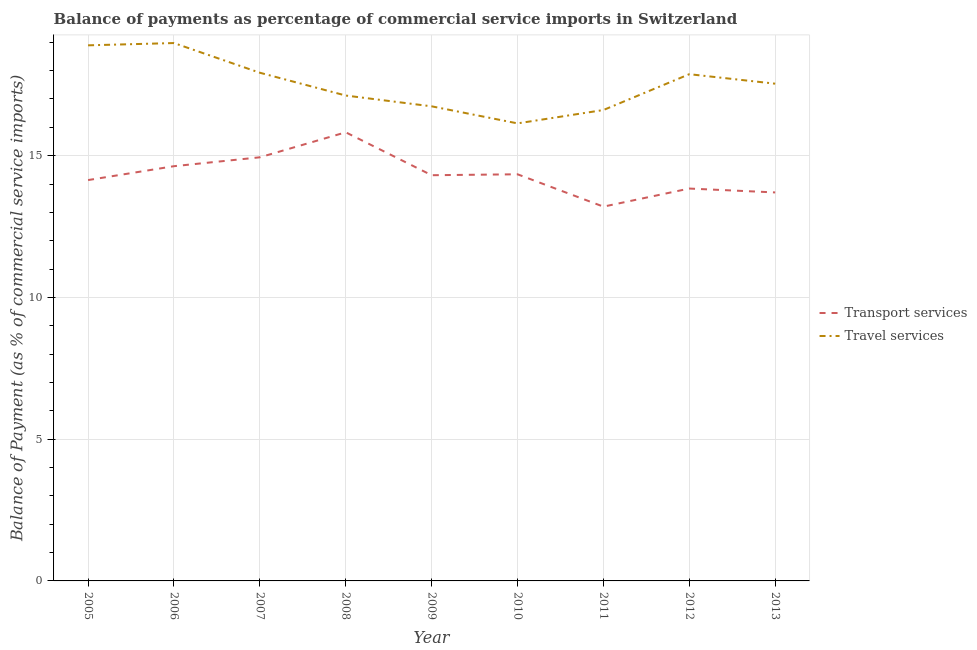Is the number of lines equal to the number of legend labels?
Provide a short and direct response. Yes. What is the balance of payments of travel services in 2012?
Your answer should be very brief. 17.87. Across all years, what is the maximum balance of payments of transport services?
Your answer should be very brief. 15.82. Across all years, what is the minimum balance of payments of travel services?
Ensure brevity in your answer.  16.14. In which year was the balance of payments of transport services maximum?
Ensure brevity in your answer.  2008. In which year was the balance of payments of travel services minimum?
Your answer should be compact. 2010. What is the total balance of payments of transport services in the graph?
Provide a short and direct response. 128.93. What is the difference between the balance of payments of travel services in 2007 and that in 2012?
Offer a very short reply. 0.05. What is the difference between the balance of payments of transport services in 2012 and the balance of payments of travel services in 2010?
Your answer should be compact. -2.3. What is the average balance of payments of transport services per year?
Your answer should be very brief. 14.33. In the year 2007, what is the difference between the balance of payments of travel services and balance of payments of transport services?
Make the answer very short. 2.98. In how many years, is the balance of payments of transport services greater than 11 %?
Offer a very short reply. 9. What is the ratio of the balance of payments of travel services in 2007 to that in 2013?
Provide a short and direct response. 1.02. Is the difference between the balance of payments of travel services in 2005 and 2010 greater than the difference between the balance of payments of transport services in 2005 and 2010?
Provide a short and direct response. Yes. What is the difference between the highest and the second highest balance of payments of travel services?
Provide a succinct answer. 0.08. What is the difference between the highest and the lowest balance of payments of transport services?
Offer a terse response. 2.62. In how many years, is the balance of payments of transport services greater than the average balance of payments of transport services taken over all years?
Provide a succinct answer. 4. Is the balance of payments of travel services strictly greater than the balance of payments of transport services over the years?
Ensure brevity in your answer.  Yes. How many lines are there?
Make the answer very short. 2. How many years are there in the graph?
Your answer should be very brief. 9. What is the difference between two consecutive major ticks on the Y-axis?
Make the answer very short. 5. Are the values on the major ticks of Y-axis written in scientific E-notation?
Provide a short and direct response. No. Does the graph contain grids?
Make the answer very short. Yes. Where does the legend appear in the graph?
Your answer should be very brief. Center right. How many legend labels are there?
Keep it short and to the point. 2. How are the legend labels stacked?
Make the answer very short. Vertical. What is the title of the graph?
Offer a terse response. Balance of payments as percentage of commercial service imports in Switzerland. What is the label or title of the X-axis?
Your answer should be very brief. Year. What is the label or title of the Y-axis?
Ensure brevity in your answer.  Balance of Payment (as % of commercial service imports). What is the Balance of Payment (as % of commercial service imports) in Transport services in 2005?
Make the answer very short. 14.14. What is the Balance of Payment (as % of commercial service imports) of Travel services in 2005?
Offer a terse response. 18.89. What is the Balance of Payment (as % of commercial service imports) in Transport services in 2006?
Give a very brief answer. 14.63. What is the Balance of Payment (as % of commercial service imports) in Travel services in 2006?
Offer a terse response. 18.97. What is the Balance of Payment (as % of commercial service imports) of Transport services in 2007?
Keep it short and to the point. 14.94. What is the Balance of Payment (as % of commercial service imports) in Travel services in 2007?
Ensure brevity in your answer.  17.92. What is the Balance of Payment (as % of commercial service imports) of Transport services in 2008?
Offer a terse response. 15.82. What is the Balance of Payment (as % of commercial service imports) of Travel services in 2008?
Your response must be concise. 17.12. What is the Balance of Payment (as % of commercial service imports) in Transport services in 2009?
Offer a terse response. 14.31. What is the Balance of Payment (as % of commercial service imports) of Travel services in 2009?
Provide a succinct answer. 16.74. What is the Balance of Payment (as % of commercial service imports) in Transport services in 2010?
Offer a very short reply. 14.34. What is the Balance of Payment (as % of commercial service imports) in Travel services in 2010?
Ensure brevity in your answer.  16.14. What is the Balance of Payment (as % of commercial service imports) in Transport services in 2011?
Offer a very short reply. 13.2. What is the Balance of Payment (as % of commercial service imports) of Travel services in 2011?
Your answer should be compact. 16.61. What is the Balance of Payment (as % of commercial service imports) in Transport services in 2012?
Your answer should be very brief. 13.84. What is the Balance of Payment (as % of commercial service imports) in Travel services in 2012?
Your answer should be compact. 17.87. What is the Balance of Payment (as % of commercial service imports) of Transport services in 2013?
Your answer should be very brief. 13.7. What is the Balance of Payment (as % of commercial service imports) of Travel services in 2013?
Offer a very short reply. 17.54. Across all years, what is the maximum Balance of Payment (as % of commercial service imports) in Transport services?
Ensure brevity in your answer.  15.82. Across all years, what is the maximum Balance of Payment (as % of commercial service imports) in Travel services?
Your answer should be compact. 18.97. Across all years, what is the minimum Balance of Payment (as % of commercial service imports) in Transport services?
Give a very brief answer. 13.2. Across all years, what is the minimum Balance of Payment (as % of commercial service imports) of Travel services?
Keep it short and to the point. 16.14. What is the total Balance of Payment (as % of commercial service imports) in Transport services in the graph?
Make the answer very short. 128.93. What is the total Balance of Payment (as % of commercial service imports) in Travel services in the graph?
Your answer should be very brief. 157.81. What is the difference between the Balance of Payment (as % of commercial service imports) in Transport services in 2005 and that in 2006?
Keep it short and to the point. -0.49. What is the difference between the Balance of Payment (as % of commercial service imports) in Travel services in 2005 and that in 2006?
Your answer should be compact. -0.08. What is the difference between the Balance of Payment (as % of commercial service imports) of Transport services in 2005 and that in 2007?
Ensure brevity in your answer.  -0.8. What is the difference between the Balance of Payment (as % of commercial service imports) of Travel services in 2005 and that in 2007?
Your response must be concise. 0.97. What is the difference between the Balance of Payment (as % of commercial service imports) of Transport services in 2005 and that in 2008?
Your answer should be compact. -1.68. What is the difference between the Balance of Payment (as % of commercial service imports) in Travel services in 2005 and that in 2008?
Your answer should be very brief. 1.77. What is the difference between the Balance of Payment (as % of commercial service imports) in Transport services in 2005 and that in 2009?
Ensure brevity in your answer.  -0.17. What is the difference between the Balance of Payment (as % of commercial service imports) in Travel services in 2005 and that in 2009?
Offer a terse response. 2.15. What is the difference between the Balance of Payment (as % of commercial service imports) in Transport services in 2005 and that in 2010?
Make the answer very short. -0.2. What is the difference between the Balance of Payment (as % of commercial service imports) in Travel services in 2005 and that in 2010?
Make the answer very short. 2.75. What is the difference between the Balance of Payment (as % of commercial service imports) of Transport services in 2005 and that in 2011?
Make the answer very short. 0.94. What is the difference between the Balance of Payment (as % of commercial service imports) of Travel services in 2005 and that in 2011?
Offer a terse response. 2.28. What is the difference between the Balance of Payment (as % of commercial service imports) of Transport services in 2005 and that in 2012?
Your answer should be very brief. 0.3. What is the difference between the Balance of Payment (as % of commercial service imports) of Travel services in 2005 and that in 2012?
Offer a terse response. 1.02. What is the difference between the Balance of Payment (as % of commercial service imports) in Transport services in 2005 and that in 2013?
Offer a very short reply. 0.44. What is the difference between the Balance of Payment (as % of commercial service imports) in Travel services in 2005 and that in 2013?
Keep it short and to the point. 1.35. What is the difference between the Balance of Payment (as % of commercial service imports) in Transport services in 2006 and that in 2007?
Provide a short and direct response. -0.31. What is the difference between the Balance of Payment (as % of commercial service imports) in Travel services in 2006 and that in 2007?
Provide a succinct answer. 1.05. What is the difference between the Balance of Payment (as % of commercial service imports) of Transport services in 2006 and that in 2008?
Offer a terse response. -1.2. What is the difference between the Balance of Payment (as % of commercial service imports) of Travel services in 2006 and that in 2008?
Provide a short and direct response. 1.85. What is the difference between the Balance of Payment (as % of commercial service imports) in Transport services in 2006 and that in 2009?
Give a very brief answer. 0.32. What is the difference between the Balance of Payment (as % of commercial service imports) of Travel services in 2006 and that in 2009?
Offer a very short reply. 2.23. What is the difference between the Balance of Payment (as % of commercial service imports) in Transport services in 2006 and that in 2010?
Keep it short and to the point. 0.29. What is the difference between the Balance of Payment (as % of commercial service imports) of Travel services in 2006 and that in 2010?
Your response must be concise. 2.83. What is the difference between the Balance of Payment (as % of commercial service imports) in Transport services in 2006 and that in 2011?
Make the answer very short. 1.43. What is the difference between the Balance of Payment (as % of commercial service imports) in Travel services in 2006 and that in 2011?
Make the answer very short. 2.36. What is the difference between the Balance of Payment (as % of commercial service imports) of Transport services in 2006 and that in 2012?
Your answer should be very brief. 0.79. What is the difference between the Balance of Payment (as % of commercial service imports) in Travel services in 2006 and that in 2012?
Provide a short and direct response. 1.1. What is the difference between the Balance of Payment (as % of commercial service imports) of Transport services in 2006 and that in 2013?
Provide a succinct answer. 0.93. What is the difference between the Balance of Payment (as % of commercial service imports) of Travel services in 2006 and that in 2013?
Offer a very short reply. 1.43. What is the difference between the Balance of Payment (as % of commercial service imports) in Transport services in 2007 and that in 2008?
Ensure brevity in your answer.  -0.88. What is the difference between the Balance of Payment (as % of commercial service imports) in Travel services in 2007 and that in 2008?
Make the answer very short. 0.8. What is the difference between the Balance of Payment (as % of commercial service imports) in Transport services in 2007 and that in 2009?
Provide a short and direct response. 0.63. What is the difference between the Balance of Payment (as % of commercial service imports) in Travel services in 2007 and that in 2009?
Provide a short and direct response. 1.18. What is the difference between the Balance of Payment (as % of commercial service imports) of Transport services in 2007 and that in 2010?
Give a very brief answer. 0.6. What is the difference between the Balance of Payment (as % of commercial service imports) of Travel services in 2007 and that in 2010?
Provide a short and direct response. 1.79. What is the difference between the Balance of Payment (as % of commercial service imports) in Transport services in 2007 and that in 2011?
Your answer should be very brief. 1.74. What is the difference between the Balance of Payment (as % of commercial service imports) in Travel services in 2007 and that in 2011?
Provide a succinct answer. 1.32. What is the difference between the Balance of Payment (as % of commercial service imports) in Transport services in 2007 and that in 2012?
Make the answer very short. 1.1. What is the difference between the Balance of Payment (as % of commercial service imports) of Travel services in 2007 and that in 2012?
Keep it short and to the point. 0.05. What is the difference between the Balance of Payment (as % of commercial service imports) in Transport services in 2007 and that in 2013?
Provide a short and direct response. 1.24. What is the difference between the Balance of Payment (as % of commercial service imports) of Travel services in 2007 and that in 2013?
Make the answer very short. 0.39. What is the difference between the Balance of Payment (as % of commercial service imports) in Transport services in 2008 and that in 2009?
Keep it short and to the point. 1.51. What is the difference between the Balance of Payment (as % of commercial service imports) of Travel services in 2008 and that in 2009?
Provide a succinct answer. 0.38. What is the difference between the Balance of Payment (as % of commercial service imports) of Transport services in 2008 and that in 2010?
Ensure brevity in your answer.  1.48. What is the difference between the Balance of Payment (as % of commercial service imports) of Travel services in 2008 and that in 2010?
Offer a terse response. 0.98. What is the difference between the Balance of Payment (as % of commercial service imports) in Transport services in 2008 and that in 2011?
Make the answer very short. 2.62. What is the difference between the Balance of Payment (as % of commercial service imports) of Travel services in 2008 and that in 2011?
Give a very brief answer. 0.51. What is the difference between the Balance of Payment (as % of commercial service imports) in Transport services in 2008 and that in 2012?
Provide a succinct answer. 1.98. What is the difference between the Balance of Payment (as % of commercial service imports) of Travel services in 2008 and that in 2012?
Your answer should be very brief. -0.75. What is the difference between the Balance of Payment (as % of commercial service imports) of Transport services in 2008 and that in 2013?
Your response must be concise. 2.12. What is the difference between the Balance of Payment (as % of commercial service imports) in Travel services in 2008 and that in 2013?
Ensure brevity in your answer.  -0.42. What is the difference between the Balance of Payment (as % of commercial service imports) in Transport services in 2009 and that in 2010?
Your answer should be compact. -0.03. What is the difference between the Balance of Payment (as % of commercial service imports) in Travel services in 2009 and that in 2010?
Offer a very short reply. 0.6. What is the difference between the Balance of Payment (as % of commercial service imports) of Transport services in 2009 and that in 2011?
Offer a terse response. 1.11. What is the difference between the Balance of Payment (as % of commercial service imports) of Travel services in 2009 and that in 2011?
Give a very brief answer. 0.13. What is the difference between the Balance of Payment (as % of commercial service imports) of Transport services in 2009 and that in 2012?
Your response must be concise. 0.47. What is the difference between the Balance of Payment (as % of commercial service imports) in Travel services in 2009 and that in 2012?
Make the answer very short. -1.13. What is the difference between the Balance of Payment (as % of commercial service imports) of Transport services in 2009 and that in 2013?
Ensure brevity in your answer.  0.61. What is the difference between the Balance of Payment (as % of commercial service imports) in Travel services in 2009 and that in 2013?
Make the answer very short. -0.8. What is the difference between the Balance of Payment (as % of commercial service imports) of Transport services in 2010 and that in 2011?
Ensure brevity in your answer.  1.14. What is the difference between the Balance of Payment (as % of commercial service imports) of Travel services in 2010 and that in 2011?
Offer a very short reply. -0.47. What is the difference between the Balance of Payment (as % of commercial service imports) of Transport services in 2010 and that in 2012?
Provide a succinct answer. 0.5. What is the difference between the Balance of Payment (as % of commercial service imports) of Travel services in 2010 and that in 2012?
Give a very brief answer. -1.74. What is the difference between the Balance of Payment (as % of commercial service imports) in Transport services in 2010 and that in 2013?
Your answer should be compact. 0.64. What is the difference between the Balance of Payment (as % of commercial service imports) of Travel services in 2010 and that in 2013?
Offer a very short reply. -1.4. What is the difference between the Balance of Payment (as % of commercial service imports) of Transport services in 2011 and that in 2012?
Your answer should be compact. -0.64. What is the difference between the Balance of Payment (as % of commercial service imports) in Travel services in 2011 and that in 2012?
Your answer should be compact. -1.26. What is the difference between the Balance of Payment (as % of commercial service imports) in Transport services in 2011 and that in 2013?
Offer a very short reply. -0.5. What is the difference between the Balance of Payment (as % of commercial service imports) in Travel services in 2011 and that in 2013?
Offer a terse response. -0.93. What is the difference between the Balance of Payment (as % of commercial service imports) in Transport services in 2012 and that in 2013?
Your response must be concise. 0.14. What is the difference between the Balance of Payment (as % of commercial service imports) in Travel services in 2012 and that in 2013?
Your answer should be compact. 0.33. What is the difference between the Balance of Payment (as % of commercial service imports) of Transport services in 2005 and the Balance of Payment (as % of commercial service imports) of Travel services in 2006?
Provide a succinct answer. -4.83. What is the difference between the Balance of Payment (as % of commercial service imports) in Transport services in 2005 and the Balance of Payment (as % of commercial service imports) in Travel services in 2007?
Your answer should be compact. -3.79. What is the difference between the Balance of Payment (as % of commercial service imports) of Transport services in 2005 and the Balance of Payment (as % of commercial service imports) of Travel services in 2008?
Give a very brief answer. -2.98. What is the difference between the Balance of Payment (as % of commercial service imports) in Transport services in 2005 and the Balance of Payment (as % of commercial service imports) in Travel services in 2009?
Offer a terse response. -2.6. What is the difference between the Balance of Payment (as % of commercial service imports) of Transport services in 2005 and the Balance of Payment (as % of commercial service imports) of Travel services in 2010?
Your response must be concise. -2. What is the difference between the Balance of Payment (as % of commercial service imports) in Transport services in 2005 and the Balance of Payment (as % of commercial service imports) in Travel services in 2011?
Your answer should be very brief. -2.47. What is the difference between the Balance of Payment (as % of commercial service imports) of Transport services in 2005 and the Balance of Payment (as % of commercial service imports) of Travel services in 2012?
Your answer should be very brief. -3.73. What is the difference between the Balance of Payment (as % of commercial service imports) in Transport services in 2005 and the Balance of Payment (as % of commercial service imports) in Travel services in 2013?
Make the answer very short. -3.4. What is the difference between the Balance of Payment (as % of commercial service imports) in Transport services in 2006 and the Balance of Payment (as % of commercial service imports) in Travel services in 2007?
Offer a terse response. -3.3. What is the difference between the Balance of Payment (as % of commercial service imports) in Transport services in 2006 and the Balance of Payment (as % of commercial service imports) in Travel services in 2008?
Your answer should be very brief. -2.49. What is the difference between the Balance of Payment (as % of commercial service imports) in Transport services in 2006 and the Balance of Payment (as % of commercial service imports) in Travel services in 2009?
Your answer should be compact. -2.11. What is the difference between the Balance of Payment (as % of commercial service imports) in Transport services in 2006 and the Balance of Payment (as % of commercial service imports) in Travel services in 2010?
Your answer should be compact. -1.51. What is the difference between the Balance of Payment (as % of commercial service imports) in Transport services in 2006 and the Balance of Payment (as % of commercial service imports) in Travel services in 2011?
Ensure brevity in your answer.  -1.98. What is the difference between the Balance of Payment (as % of commercial service imports) of Transport services in 2006 and the Balance of Payment (as % of commercial service imports) of Travel services in 2012?
Your response must be concise. -3.25. What is the difference between the Balance of Payment (as % of commercial service imports) in Transport services in 2006 and the Balance of Payment (as % of commercial service imports) in Travel services in 2013?
Offer a very short reply. -2.91. What is the difference between the Balance of Payment (as % of commercial service imports) of Transport services in 2007 and the Balance of Payment (as % of commercial service imports) of Travel services in 2008?
Provide a succinct answer. -2.18. What is the difference between the Balance of Payment (as % of commercial service imports) in Transport services in 2007 and the Balance of Payment (as % of commercial service imports) in Travel services in 2009?
Make the answer very short. -1.8. What is the difference between the Balance of Payment (as % of commercial service imports) in Transport services in 2007 and the Balance of Payment (as % of commercial service imports) in Travel services in 2010?
Your answer should be compact. -1.2. What is the difference between the Balance of Payment (as % of commercial service imports) of Transport services in 2007 and the Balance of Payment (as % of commercial service imports) of Travel services in 2011?
Make the answer very short. -1.67. What is the difference between the Balance of Payment (as % of commercial service imports) in Transport services in 2007 and the Balance of Payment (as % of commercial service imports) in Travel services in 2012?
Provide a short and direct response. -2.93. What is the difference between the Balance of Payment (as % of commercial service imports) of Transport services in 2007 and the Balance of Payment (as % of commercial service imports) of Travel services in 2013?
Make the answer very short. -2.6. What is the difference between the Balance of Payment (as % of commercial service imports) in Transport services in 2008 and the Balance of Payment (as % of commercial service imports) in Travel services in 2009?
Provide a short and direct response. -0.92. What is the difference between the Balance of Payment (as % of commercial service imports) in Transport services in 2008 and the Balance of Payment (as % of commercial service imports) in Travel services in 2010?
Ensure brevity in your answer.  -0.31. What is the difference between the Balance of Payment (as % of commercial service imports) in Transport services in 2008 and the Balance of Payment (as % of commercial service imports) in Travel services in 2011?
Ensure brevity in your answer.  -0.79. What is the difference between the Balance of Payment (as % of commercial service imports) in Transport services in 2008 and the Balance of Payment (as % of commercial service imports) in Travel services in 2012?
Provide a short and direct response. -2.05. What is the difference between the Balance of Payment (as % of commercial service imports) in Transport services in 2008 and the Balance of Payment (as % of commercial service imports) in Travel services in 2013?
Ensure brevity in your answer.  -1.72. What is the difference between the Balance of Payment (as % of commercial service imports) of Transport services in 2009 and the Balance of Payment (as % of commercial service imports) of Travel services in 2010?
Keep it short and to the point. -1.83. What is the difference between the Balance of Payment (as % of commercial service imports) of Transport services in 2009 and the Balance of Payment (as % of commercial service imports) of Travel services in 2011?
Provide a succinct answer. -2.3. What is the difference between the Balance of Payment (as % of commercial service imports) in Transport services in 2009 and the Balance of Payment (as % of commercial service imports) in Travel services in 2012?
Ensure brevity in your answer.  -3.56. What is the difference between the Balance of Payment (as % of commercial service imports) of Transport services in 2009 and the Balance of Payment (as % of commercial service imports) of Travel services in 2013?
Give a very brief answer. -3.23. What is the difference between the Balance of Payment (as % of commercial service imports) of Transport services in 2010 and the Balance of Payment (as % of commercial service imports) of Travel services in 2011?
Ensure brevity in your answer.  -2.27. What is the difference between the Balance of Payment (as % of commercial service imports) of Transport services in 2010 and the Balance of Payment (as % of commercial service imports) of Travel services in 2012?
Make the answer very short. -3.53. What is the difference between the Balance of Payment (as % of commercial service imports) in Transport services in 2010 and the Balance of Payment (as % of commercial service imports) in Travel services in 2013?
Your answer should be very brief. -3.2. What is the difference between the Balance of Payment (as % of commercial service imports) of Transport services in 2011 and the Balance of Payment (as % of commercial service imports) of Travel services in 2012?
Your answer should be compact. -4.67. What is the difference between the Balance of Payment (as % of commercial service imports) of Transport services in 2011 and the Balance of Payment (as % of commercial service imports) of Travel services in 2013?
Your response must be concise. -4.34. What is the difference between the Balance of Payment (as % of commercial service imports) of Transport services in 2012 and the Balance of Payment (as % of commercial service imports) of Travel services in 2013?
Provide a short and direct response. -3.7. What is the average Balance of Payment (as % of commercial service imports) of Transport services per year?
Give a very brief answer. 14.33. What is the average Balance of Payment (as % of commercial service imports) of Travel services per year?
Keep it short and to the point. 17.53. In the year 2005, what is the difference between the Balance of Payment (as % of commercial service imports) of Transport services and Balance of Payment (as % of commercial service imports) of Travel services?
Ensure brevity in your answer.  -4.75. In the year 2006, what is the difference between the Balance of Payment (as % of commercial service imports) of Transport services and Balance of Payment (as % of commercial service imports) of Travel services?
Give a very brief answer. -4.34. In the year 2007, what is the difference between the Balance of Payment (as % of commercial service imports) in Transport services and Balance of Payment (as % of commercial service imports) in Travel services?
Ensure brevity in your answer.  -2.98. In the year 2008, what is the difference between the Balance of Payment (as % of commercial service imports) of Transport services and Balance of Payment (as % of commercial service imports) of Travel services?
Make the answer very short. -1.3. In the year 2009, what is the difference between the Balance of Payment (as % of commercial service imports) in Transport services and Balance of Payment (as % of commercial service imports) in Travel services?
Offer a very short reply. -2.43. In the year 2010, what is the difference between the Balance of Payment (as % of commercial service imports) in Transport services and Balance of Payment (as % of commercial service imports) in Travel services?
Your answer should be very brief. -1.8. In the year 2011, what is the difference between the Balance of Payment (as % of commercial service imports) of Transport services and Balance of Payment (as % of commercial service imports) of Travel services?
Provide a succinct answer. -3.41. In the year 2012, what is the difference between the Balance of Payment (as % of commercial service imports) of Transport services and Balance of Payment (as % of commercial service imports) of Travel services?
Make the answer very short. -4.03. In the year 2013, what is the difference between the Balance of Payment (as % of commercial service imports) in Transport services and Balance of Payment (as % of commercial service imports) in Travel services?
Your answer should be compact. -3.84. What is the ratio of the Balance of Payment (as % of commercial service imports) in Transport services in 2005 to that in 2006?
Offer a very short reply. 0.97. What is the ratio of the Balance of Payment (as % of commercial service imports) in Transport services in 2005 to that in 2007?
Your response must be concise. 0.95. What is the ratio of the Balance of Payment (as % of commercial service imports) in Travel services in 2005 to that in 2007?
Keep it short and to the point. 1.05. What is the ratio of the Balance of Payment (as % of commercial service imports) in Transport services in 2005 to that in 2008?
Your answer should be compact. 0.89. What is the ratio of the Balance of Payment (as % of commercial service imports) in Travel services in 2005 to that in 2008?
Give a very brief answer. 1.1. What is the ratio of the Balance of Payment (as % of commercial service imports) in Travel services in 2005 to that in 2009?
Provide a succinct answer. 1.13. What is the ratio of the Balance of Payment (as % of commercial service imports) in Transport services in 2005 to that in 2010?
Offer a terse response. 0.99. What is the ratio of the Balance of Payment (as % of commercial service imports) in Travel services in 2005 to that in 2010?
Provide a succinct answer. 1.17. What is the ratio of the Balance of Payment (as % of commercial service imports) in Transport services in 2005 to that in 2011?
Keep it short and to the point. 1.07. What is the ratio of the Balance of Payment (as % of commercial service imports) of Travel services in 2005 to that in 2011?
Offer a very short reply. 1.14. What is the ratio of the Balance of Payment (as % of commercial service imports) in Transport services in 2005 to that in 2012?
Provide a short and direct response. 1.02. What is the ratio of the Balance of Payment (as % of commercial service imports) in Travel services in 2005 to that in 2012?
Offer a terse response. 1.06. What is the ratio of the Balance of Payment (as % of commercial service imports) of Transport services in 2005 to that in 2013?
Make the answer very short. 1.03. What is the ratio of the Balance of Payment (as % of commercial service imports) in Travel services in 2005 to that in 2013?
Ensure brevity in your answer.  1.08. What is the ratio of the Balance of Payment (as % of commercial service imports) of Travel services in 2006 to that in 2007?
Provide a succinct answer. 1.06. What is the ratio of the Balance of Payment (as % of commercial service imports) in Transport services in 2006 to that in 2008?
Your answer should be very brief. 0.92. What is the ratio of the Balance of Payment (as % of commercial service imports) of Travel services in 2006 to that in 2008?
Offer a very short reply. 1.11. What is the ratio of the Balance of Payment (as % of commercial service imports) of Transport services in 2006 to that in 2009?
Keep it short and to the point. 1.02. What is the ratio of the Balance of Payment (as % of commercial service imports) of Travel services in 2006 to that in 2009?
Make the answer very short. 1.13. What is the ratio of the Balance of Payment (as % of commercial service imports) in Transport services in 2006 to that in 2010?
Make the answer very short. 1.02. What is the ratio of the Balance of Payment (as % of commercial service imports) of Travel services in 2006 to that in 2010?
Provide a short and direct response. 1.18. What is the ratio of the Balance of Payment (as % of commercial service imports) of Transport services in 2006 to that in 2011?
Provide a short and direct response. 1.11. What is the ratio of the Balance of Payment (as % of commercial service imports) in Travel services in 2006 to that in 2011?
Make the answer very short. 1.14. What is the ratio of the Balance of Payment (as % of commercial service imports) of Transport services in 2006 to that in 2012?
Give a very brief answer. 1.06. What is the ratio of the Balance of Payment (as % of commercial service imports) in Travel services in 2006 to that in 2012?
Your answer should be compact. 1.06. What is the ratio of the Balance of Payment (as % of commercial service imports) of Transport services in 2006 to that in 2013?
Offer a terse response. 1.07. What is the ratio of the Balance of Payment (as % of commercial service imports) of Travel services in 2006 to that in 2013?
Provide a short and direct response. 1.08. What is the ratio of the Balance of Payment (as % of commercial service imports) of Transport services in 2007 to that in 2008?
Ensure brevity in your answer.  0.94. What is the ratio of the Balance of Payment (as % of commercial service imports) of Travel services in 2007 to that in 2008?
Ensure brevity in your answer.  1.05. What is the ratio of the Balance of Payment (as % of commercial service imports) of Transport services in 2007 to that in 2009?
Keep it short and to the point. 1.04. What is the ratio of the Balance of Payment (as % of commercial service imports) of Travel services in 2007 to that in 2009?
Your response must be concise. 1.07. What is the ratio of the Balance of Payment (as % of commercial service imports) in Transport services in 2007 to that in 2010?
Your answer should be compact. 1.04. What is the ratio of the Balance of Payment (as % of commercial service imports) of Travel services in 2007 to that in 2010?
Make the answer very short. 1.11. What is the ratio of the Balance of Payment (as % of commercial service imports) in Transport services in 2007 to that in 2011?
Offer a very short reply. 1.13. What is the ratio of the Balance of Payment (as % of commercial service imports) in Travel services in 2007 to that in 2011?
Your response must be concise. 1.08. What is the ratio of the Balance of Payment (as % of commercial service imports) in Transport services in 2007 to that in 2012?
Offer a very short reply. 1.08. What is the ratio of the Balance of Payment (as % of commercial service imports) of Transport services in 2007 to that in 2013?
Make the answer very short. 1.09. What is the ratio of the Balance of Payment (as % of commercial service imports) of Transport services in 2008 to that in 2009?
Your response must be concise. 1.11. What is the ratio of the Balance of Payment (as % of commercial service imports) of Travel services in 2008 to that in 2009?
Your answer should be compact. 1.02. What is the ratio of the Balance of Payment (as % of commercial service imports) of Transport services in 2008 to that in 2010?
Make the answer very short. 1.1. What is the ratio of the Balance of Payment (as % of commercial service imports) of Travel services in 2008 to that in 2010?
Ensure brevity in your answer.  1.06. What is the ratio of the Balance of Payment (as % of commercial service imports) in Transport services in 2008 to that in 2011?
Offer a very short reply. 1.2. What is the ratio of the Balance of Payment (as % of commercial service imports) of Travel services in 2008 to that in 2011?
Make the answer very short. 1.03. What is the ratio of the Balance of Payment (as % of commercial service imports) of Transport services in 2008 to that in 2012?
Ensure brevity in your answer.  1.14. What is the ratio of the Balance of Payment (as % of commercial service imports) in Travel services in 2008 to that in 2012?
Offer a terse response. 0.96. What is the ratio of the Balance of Payment (as % of commercial service imports) of Transport services in 2008 to that in 2013?
Make the answer very short. 1.15. What is the ratio of the Balance of Payment (as % of commercial service imports) of Travel services in 2008 to that in 2013?
Your response must be concise. 0.98. What is the ratio of the Balance of Payment (as % of commercial service imports) in Travel services in 2009 to that in 2010?
Your answer should be compact. 1.04. What is the ratio of the Balance of Payment (as % of commercial service imports) of Transport services in 2009 to that in 2011?
Offer a very short reply. 1.08. What is the ratio of the Balance of Payment (as % of commercial service imports) of Travel services in 2009 to that in 2011?
Offer a terse response. 1.01. What is the ratio of the Balance of Payment (as % of commercial service imports) of Transport services in 2009 to that in 2012?
Give a very brief answer. 1.03. What is the ratio of the Balance of Payment (as % of commercial service imports) of Travel services in 2009 to that in 2012?
Keep it short and to the point. 0.94. What is the ratio of the Balance of Payment (as % of commercial service imports) of Transport services in 2009 to that in 2013?
Provide a short and direct response. 1.04. What is the ratio of the Balance of Payment (as % of commercial service imports) of Travel services in 2009 to that in 2013?
Give a very brief answer. 0.95. What is the ratio of the Balance of Payment (as % of commercial service imports) of Transport services in 2010 to that in 2011?
Your response must be concise. 1.09. What is the ratio of the Balance of Payment (as % of commercial service imports) in Travel services in 2010 to that in 2011?
Your answer should be compact. 0.97. What is the ratio of the Balance of Payment (as % of commercial service imports) in Transport services in 2010 to that in 2012?
Your answer should be compact. 1.04. What is the ratio of the Balance of Payment (as % of commercial service imports) of Travel services in 2010 to that in 2012?
Your answer should be compact. 0.9. What is the ratio of the Balance of Payment (as % of commercial service imports) in Transport services in 2010 to that in 2013?
Your answer should be very brief. 1.05. What is the ratio of the Balance of Payment (as % of commercial service imports) of Travel services in 2010 to that in 2013?
Make the answer very short. 0.92. What is the ratio of the Balance of Payment (as % of commercial service imports) in Transport services in 2011 to that in 2012?
Ensure brevity in your answer.  0.95. What is the ratio of the Balance of Payment (as % of commercial service imports) in Travel services in 2011 to that in 2012?
Give a very brief answer. 0.93. What is the ratio of the Balance of Payment (as % of commercial service imports) in Transport services in 2011 to that in 2013?
Your answer should be compact. 0.96. What is the ratio of the Balance of Payment (as % of commercial service imports) in Travel services in 2011 to that in 2013?
Provide a succinct answer. 0.95. What is the ratio of the Balance of Payment (as % of commercial service imports) in Transport services in 2012 to that in 2013?
Offer a terse response. 1.01. What is the ratio of the Balance of Payment (as % of commercial service imports) of Travel services in 2012 to that in 2013?
Offer a very short reply. 1.02. What is the difference between the highest and the second highest Balance of Payment (as % of commercial service imports) in Transport services?
Your answer should be very brief. 0.88. What is the difference between the highest and the second highest Balance of Payment (as % of commercial service imports) of Travel services?
Provide a short and direct response. 0.08. What is the difference between the highest and the lowest Balance of Payment (as % of commercial service imports) in Transport services?
Provide a succinct answer. 2.62. What is the difference between the highest and the lowest Balance of Payment (as % of commercial service imports) in Travel services?
Give a very brief answer. 2.83. 